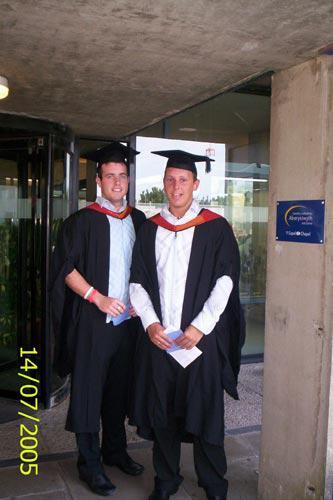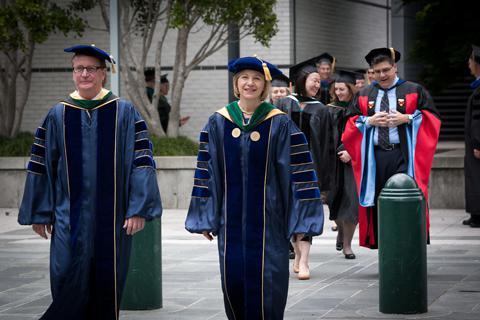The first image is the image on the left, the second image is the image on the right. Considering the images on both sides, is "The image on the left does not contain more than two people." valid? Answer yes or no. Yes. 